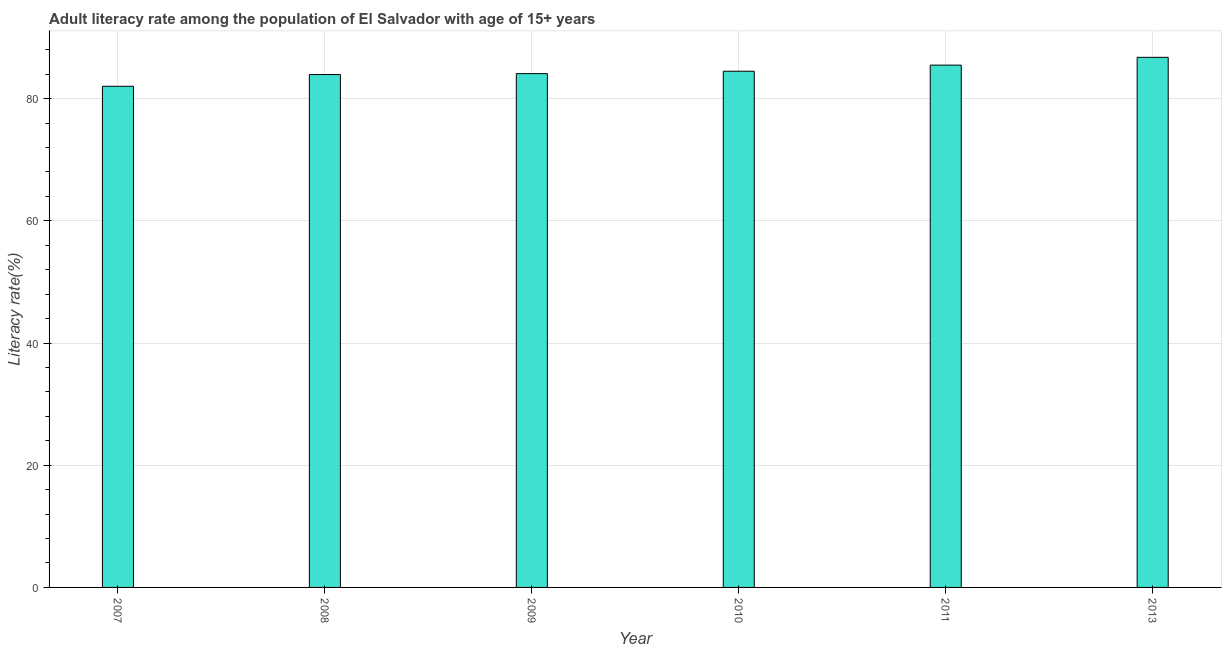Does the graph contain grids?
Your answer should be compact. Yes. What is the title of the graph?
Provide a short and direct response. Adult literacy rate among the population of El Salvador with age of 15+ years. What is the label or title of the Y-axis?
Your answer should be very brief. Literacy rate(%). What is the adult literacy rate in 2007?
Provide a short and direct response. 82.03. Across all years, what is the maximum adult literacy rate?
Offer a very short reply. 86.77. Across all years, what is the minimum adult literacy rate?
Offer a very short reply. 82.03. In which year was the adult literacy rate maximum?
Your response must be concise. 2013. In which year was the adult literacy rate minimum?
Offer a very short reply. 2007. What is the sum of the adult literacy rate?
Make the answer very short. 506.84. What is the difference between the adult literacy rate in 2010 and 2013?
Your response must be concise. -2.27. What is the average adult literacy rate per year?
Your response must be concise. 84.47. What is the median adult literacy rate?
Your answer should be very brief. 84.3. Do a majority of the years between 2010 and 2007 (inclusive) have adult literacy rate greater than 8 %?
Offer a terse response. Yes. What is the ratio of the adult literacy rate in 2010 to that in 2011?
Give a very brief answer. 0.99. Is the adult literacy rate in 2011 less than that in 2013?
Provide a succinct answer. Yes. What is the difference between the highest and the second highest adult literacy rate?
Make the answer very short. 1.27. What is the difference between the highest and the lowest adult literacy rate?
Provide a short and direct response. 4.74. In how many years, is the adult literacy rate greater than the average adult literacy rate taken over all years?
Your response must be concise. 3. How many bars are there?
Provide a short and direct response. 6. How many years are there in the graph?
Your answer should be very brief. 6. What is the difference between two consecutive major ticks on the Y-axis?
Provide a short and direct response. 20. What is the Literacy rate(%) in 2007?
Ensure brevity in your answer.  82.03. What is the Literacy rate(%) of 2008?
Ensure brevity in your answer.  83.95. What is the Literacy rate(%) of 2009?
Provide a short and direct response. 84.1. What is the Literacy rate(%) in 2010?
Provide a succinct answer. 84.49. What is the Literacy rate(%) of 2011?
Make the answer very short. 85.49. What is the Literacy rate(%) in 2013?
Ensure brevity in your answer.  86.77. What is the difference between the Literacy rate(%) in 2007 and 2008?
Ensure brevity in your answer.  -1.92. What is the difference between the Literacy rate(%) in 2007 and 2009?
Provide a short and direct response. -2.07. What is the difference between the Literacy rate(%) in 2007 and 2010?
Offer a very short reply. -2.46. What is the difference between the Literacy rate(%) in 2007 and 2011?
Provide a succinct answer. -3.47. What is the difference between the Literacy rate(%) in 2007 and 2013?
Make the answer very short. -4.74. What is the difference between the Literacy rate(%) in 2008 and 2009?
Your answer should be very brief. -0.15. What is the difference between the Literacy rate(%) in 2008 and 2010?
Provide a short and direct response. -0.54. What is the difference between the Literacy rate(%) in 2008 and 2011?
Give a very brief answer. -1.54. What is the difference between the Literacy rate(%) in 2008 and 2013?
Offer a very short reply. -2.82. What is the difference between the Literacy rate(%) in 2009 and 2010?
Your answer should be compact. -0.39. What is the difference between the Literacy rate(%) in 2009 and 2011?
Offer a very short reply. -1.39. What is the difference between the Literacy rate(%) in 2009 and 2013?
Offer a very short reply. -2.66. What is the difference between the Literacy rate(%) in 2010 and 2011?
Keep it short and to the point. -1. What is the difference between the Literacy rate(%) in 2010 and 2013?
Keep it short and to the point. -2.27. What is the difference between the Literacy rate(%) in 2011 and 2013?
Your answer should be very brief. -1.27. What is the ratio of the Literacy rate(%) in 2007 to that in 2008?
Provide a short and direct response. 0.98. What is the ratio of the Literacy rate(%) in 2007 to that in 2009?
Your answer should be very brief. 0.97. What is the ratio of the Literacy rate(%) in 2007 to that in 2010?
Make the answer very short. 0.97. What is the ratio of the Literacy rate(%) in 2007 to that in 2013?
Your answer should be very brief. 0.94. What is the ratio of the Literacy rate(%) in 2008 to that in 2009?
Provide a succinct answer. 1. What is the ratio of the Literacy rate(%) in 2008 to that in 2010?
Keep it short and to the point. 0.99. What is the ratio of the Literacy rate(%) in 2008 to that in 2011?
Your response must be concise. 0.98. What is the ratio of the Literacy rate(%) in 2008 to that in 2013?
Your answer should be compact. 0.97. What is the ratio of the Literacy rate(%) in 2009 to that in 2011?
Make the answer very short. 0.98. What is the ratio of the Literacy rate(%) in 2010 to that in 2013?
Provide a short and direct response. 0.97. What is the ratio of the Literacy rate(%) in 2011 to that in 2013?
Offer a terse response. 0.98. 